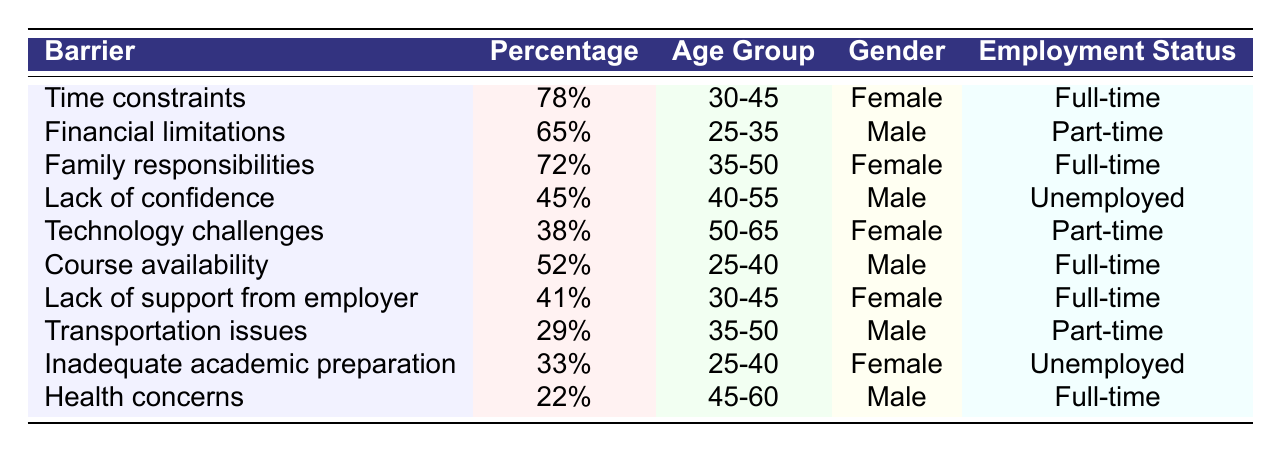What is the percentage of respondents who identified "Time constraints" as a barrier? The table lists "Time constraints" with a percentage of 78% in the first row.
Answer: 78% Which barrier has the lowest percentage reported? The barriers and their percentages show that "Health concerns" has the lowest percentage at 22%.
Answer: 22% How many barriers have a percentage of 50 or more? The table shows five barriers with percentages of 50 or more: "Time constraints" (78%), "Financial limitations" (65%), "Family responsibilities" (72%), "Course availability" (52%), and "Lack of support from employer" (41%). Therefore, there are five such barriers.
Answer: 5 What age group reported the highest percentage for "Family responsibilities"? The "Family responsibilities" barrier shows a percentage of 72% for the age group 35-50, which is the only value for this barrier, confirming this age group reported the highest percentage.
Answer: 35-50 Is there a barrier that reports a higher percentage for female respondents than male respondents? Yes, "Time constraints" (78%) and "Family responsibilities" (72%) are barriers reported by female respondents with higher percentages than any male barriers.
Answer: Yes What is the average percentage of barriers for respondents aged 30-45? The percentages for barriers affecting this age group are "Time constraints" (78%) and "Lack of support from employer" (41%). To find the average: (78 + 41) / 2 = 59.5.
Answer: 59.5 Which gender has reported higher percentages for barriers overall, based on the table? This requires comparing the percentages: Female respondents have higher percentages (78%, 72%, 41%, 38%, 33%) totalling 262%. Male respondents have (65%, 45%, 52%, 29%, 22%) totalling 213%. Hence, females reported higher overall.
Answer: Female How does the percentage of "Technology challenges" for female respondents compare to "Transportation issues" for male respondents? "Technology challenges" has a percentage of 38% for females, while "Transportation issues" has a percentage of 29% for males. Comparing these, the percentage for females facing technology challenges is higher.
Answer: Higher for females What is the difference in percentage between "Lack of support from employer" and "Inadequate academic preparation"? The percentage for "Lack of support from employer" is 41%, and for "Inadequate academic preparation," it is 33%. The difference is calculated as 41 - 33 = 8.
Answer: 8 Which barrier is most reported by full-time employed individuals? Among the barriers, "Time constraints" is reported with the highest percentage of 78% by full-time employed individuals compared to others.
Answer: Time constraints 